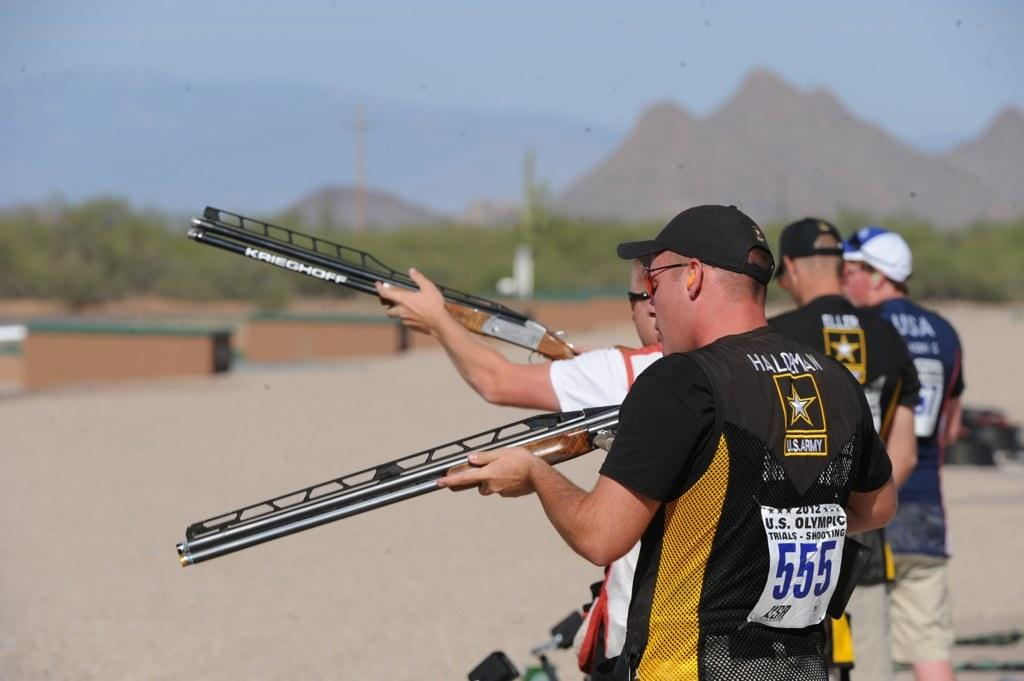What are the people in the middle of the image doing? The people are standing in the middle of the image and holding weapons. What objects can be seen in the image besides the people? There are poles and trees visible in the image. What is the background of the image like? The background of the image includes hills and the sky. What type of bird is perched on the dad's shoulder in the image? There is no bird or dad present in the image; it only features people holding weapons and other objects. 